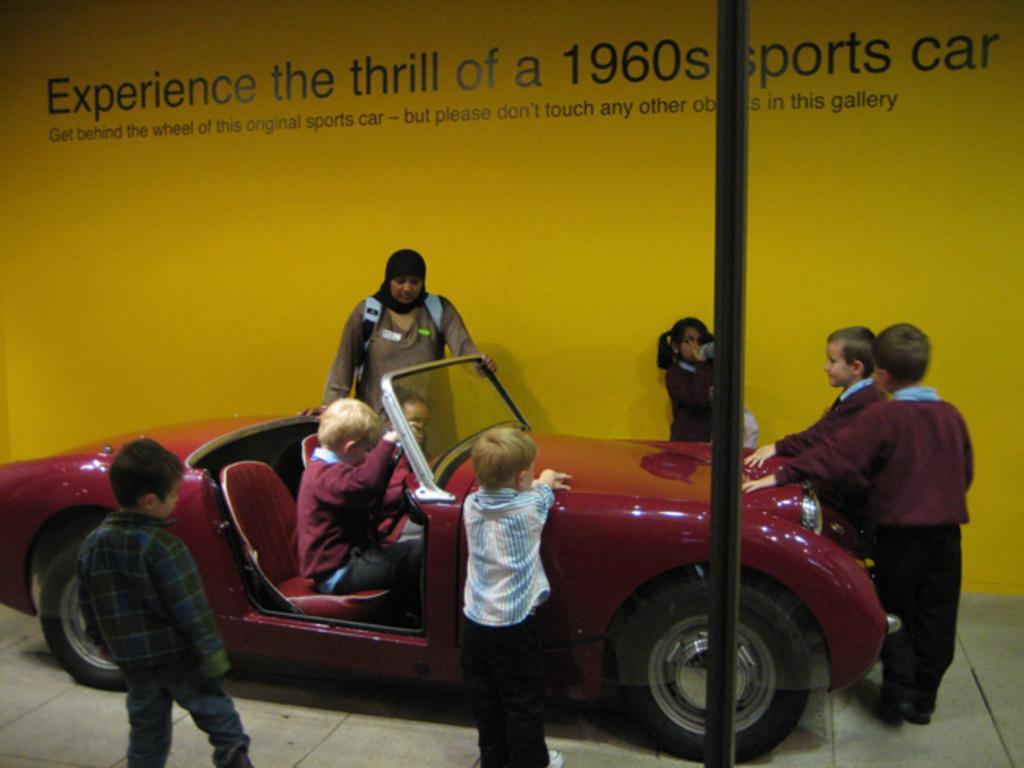Please provide a concise description of this image. In this image I can see group of people, some are standing and some are sitting. In front I can see the car and the car is in red color and I can see two persons sitting in the car and the background is in yellow color. In front I can see the pole. 